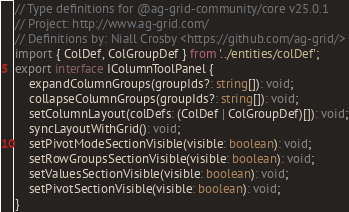<code> <loc_0><loc_0><loc_500><loc_500><_TypeScript_>// Type definitions for @ag-grid-community/core v25.0.1
// Project: http://www.ag-grid.com/
// Definitions by: Niall Crosby <https://github.com/ag-grid/>
import { ColDef, ColGroupDef } from '../entities/colDef';
export interface IColumnToolPanel {
    expandColumnGroups(groupIds?: string[]): void;
    collapseColumnGroups(groupIds?: string[]): void;
    setColumnLayout(colDefs: (ColDef | ColGroupDef)[]): void;
    syncLayoutWithGrid(): void;
    setPivotModeSectionVisible(visible: boolean): void;
    setRowGroupsSectionVisible(visible: boolean): void;
    setValuesSectionVisible(visible: boolean): void;
    setPivotSectionVisible(visible: boolean): void;
}
</code> 